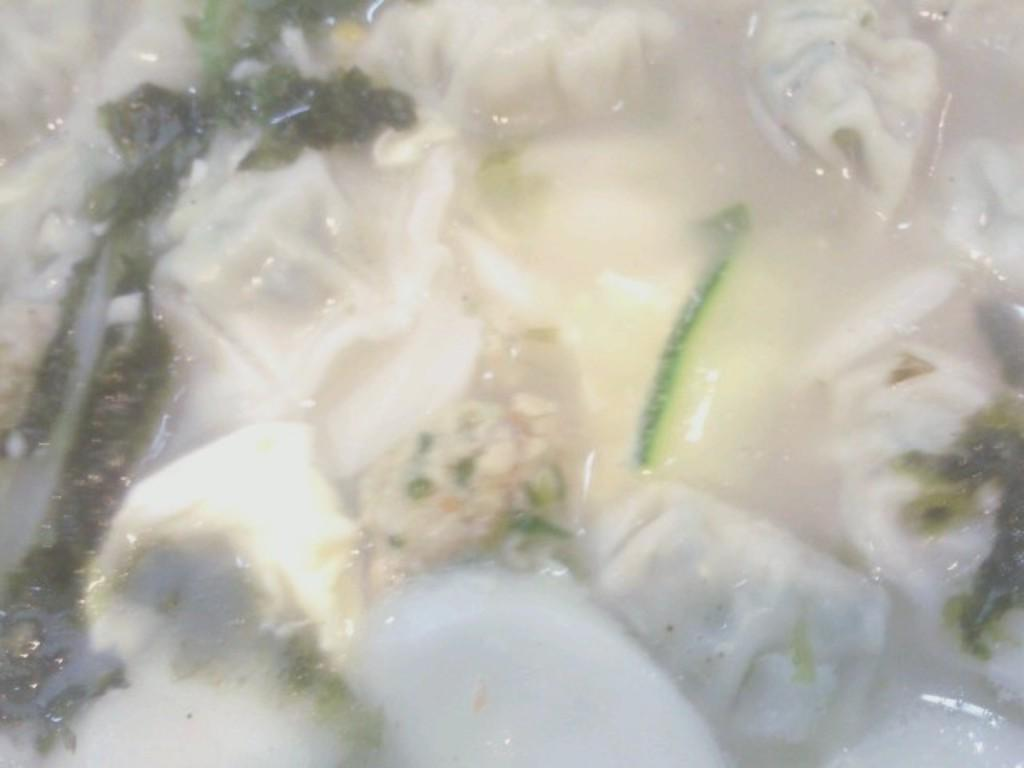What type of food item is visible in the image? Unfortunately, the specific type of food item cannot be determined from the given facts. What else can be seen in the image besides the food item? There are leaves in the image. How many boats can be seen in the image? There are no boats present in the image. Is there a bike visible in the image? There is no bike present in the image. 